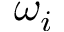Convert formula to latex. <formula><loc_0><loc_0><loc_500><loc_500>\omega _ { i }</formula> 